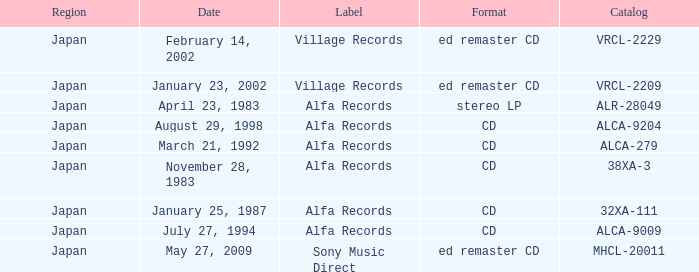What is the format of the date February 14, 2002? Ed remaster cd. 